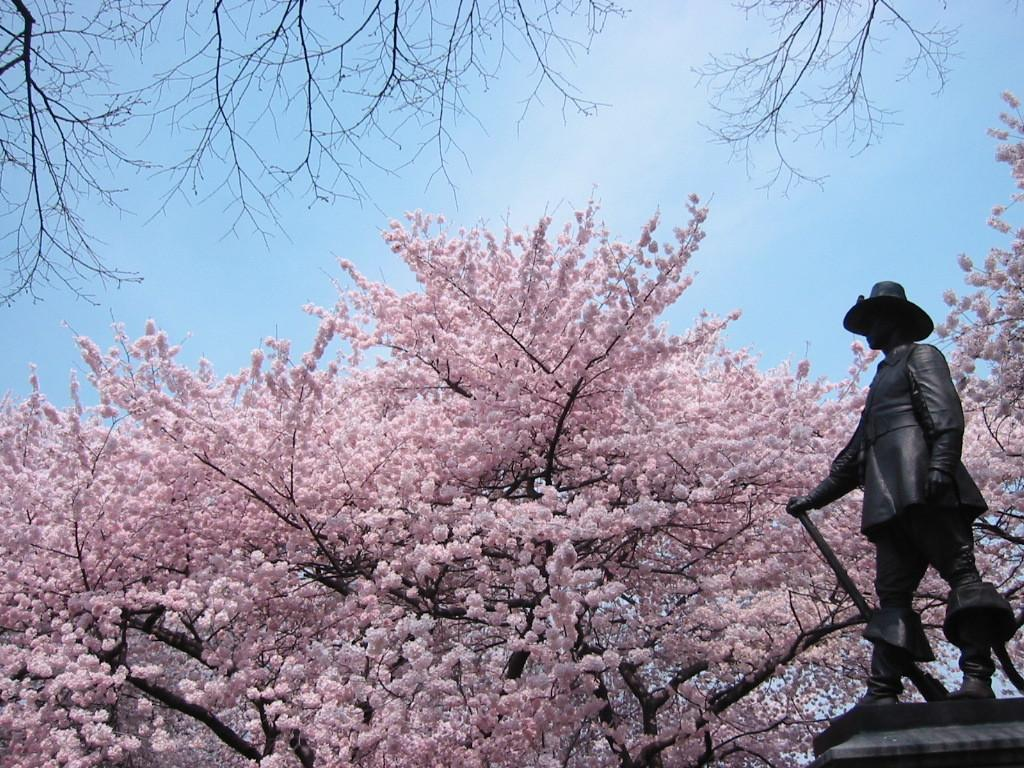What type of plant can be seen in the image? There is a tree in the image. What is unique about the tree's appearance? The tree is pink in color. Where is the statue located in the image? The statue is on the right side of the image. What can be seen in the background of the image? There is a sky visible in the background of the image. Can you tell me what type of receipt is hanging from the tree in the image? There is no receipt present in the image; it features a pink tree and a statue. What type of cloth is draped over the statue in the image? There is no cloth draped over the statue in the image; the statue is simply standing on the right side of the image. 